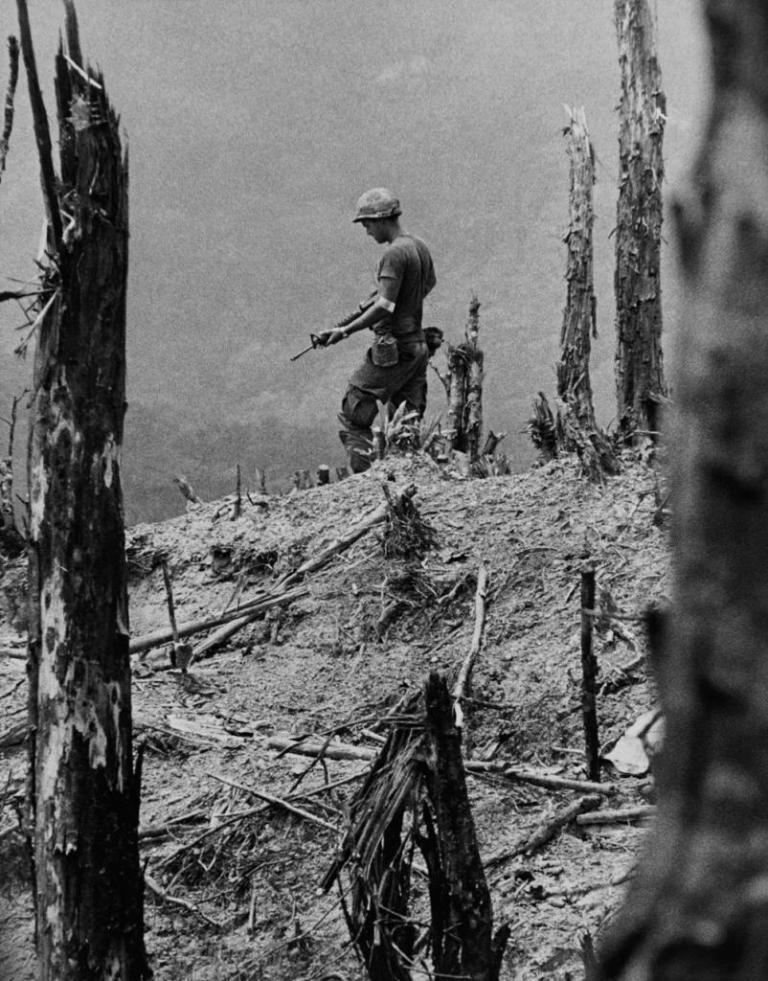How would you summarize this image in a sentence or two? It is a black and white image, there are logs and dried sticks. In the middle a man is there. She wore t-shirt, trouser, cap and also holding a weapon in his hands. 